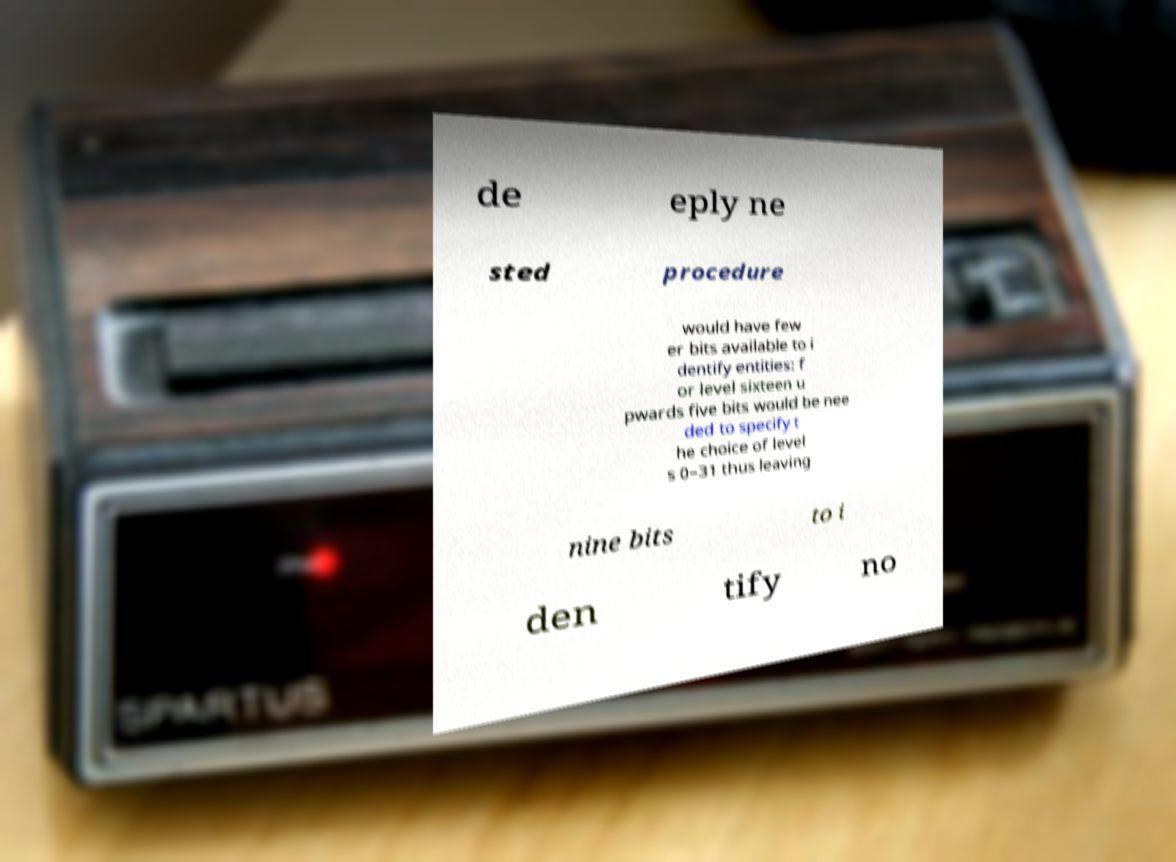Could you assist in decoding the text presented in this image and type it out clearly? de eply ne sted procedure would have few er bits available to i dentify entities: f or level sixteen u pwards five bits would be nee ded to specify t he choice of level s 0–31 thus leaving nine bits to i den tify no 